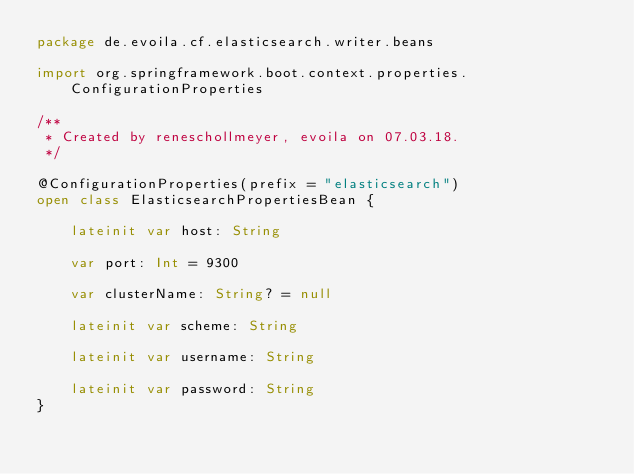Convert code to text. <code><loc_0><loc_0><loc_500><loc_500><_Kotlin_>package de.evoila.cf.elasticsearch.writer.beans

import org.springframework.boot.context.properties.ConfigurationProperties

/**
 * Created by reneschollmeyer, evoila on 07.03.18.
 */

@ConfigurationProperties(prefix = "elasticsearch")
open class ElasticsearchPropertiesBean {

    lateinit var host: String

    var port: Int = 9300

    var clusterName: String? = null

    lateinit var scheme: String

    lateinit var username: String

    lateinit var password: String
}</code> 